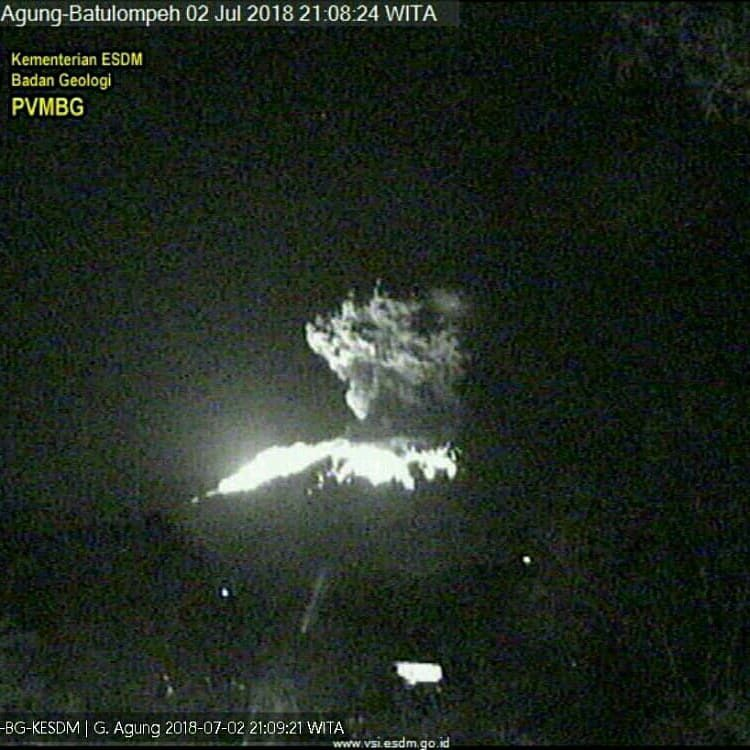Imagine that the volcano emitted not just lava but magical gemstones. What impact would this have on the local economy and culture? If the volcano started emitting magical gemstones, it would dramatically alter both the local economy and culture. Such an event would transform the area into a bustling hub of activity. Treasure hunters, tourists, and investors would flock to the region, leading to rapid economic growth. Local culture would become steeped in legends and stories about the magical properties of these stones. New businesses would emerge, focused on gemstone trade, tourism, and even crafting magical artifacts. This influx of wealth and diversity might lead to significant social changes, with traditional customs blending with new influences brought by the wave of newcomers. The local government would need to manage this boom carefully to ensure sustainable growth and protect the unique cultural heritage of the area. 